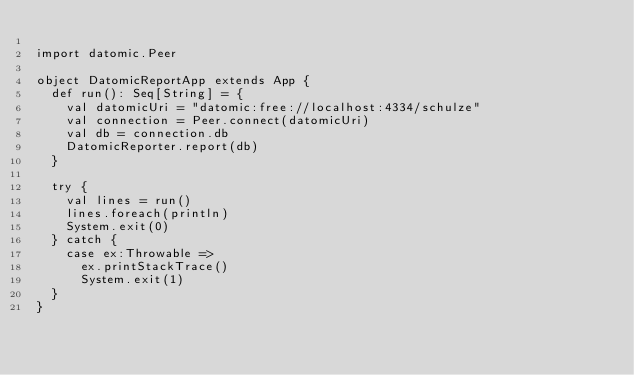Convert code to text. <code><loc_0><loc_0><loc_500><loc_500><_Scala_>
import datomic.Peer

object DatomicReportApp extends App {
  def run(): Seq[String] = {
    val datomicUri = "datomic:free://localhost:4334/schulze"
    val connection = Peer.connect(datomicUri)
    val db = connection.db
    DatomicReporter.report(db)
  }

  try {
    val lines = run()
    lines.foreach(println)
    System.exit(0)
  } catch {
    case ex:Throwable =>
      ex.printStackTrace()
      System.exit(1)
  }
}
</code> 